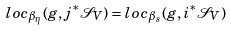Convert formula to latex. <formula><loc_0><loc_0><loc_500><loc_500>l o c _ { \beta _ { \eta } } ( g , j ^ { \ast } \mathcal { S } _ { V } ) = l o c _ { \beta _ { s } } ( g , i ^ { \ast } \mathcal { S } _ { V } )</formula> 